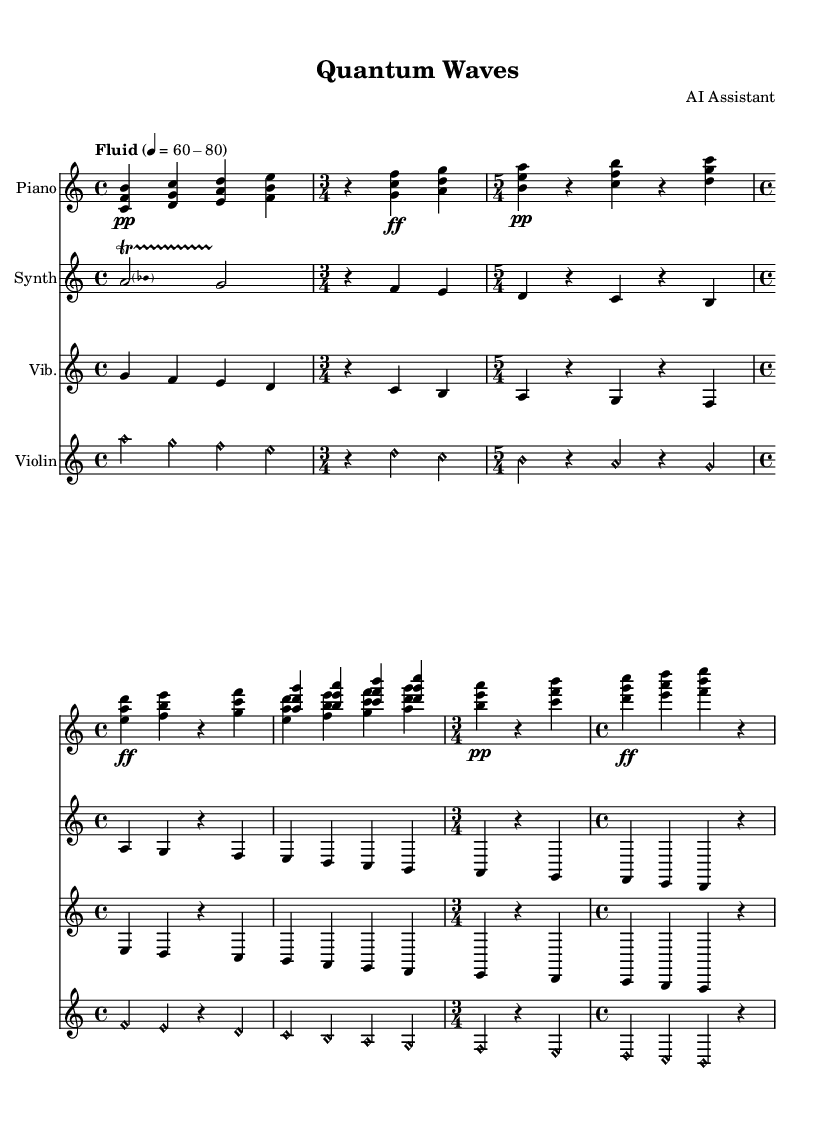What is the tempo marking of this composition? The tempo marking is indicated at the beginning of the score as "Fluid" with a range of 60-80 beats per minute, showing the desired pace for performance.
Answer: Fluid 60-80 What is the time signature of the first measure? The first measure has a time signature of 4/4, as explicitly notated at the beginning of the piece under the global settings.
Answer: 4/4 How many measures are there in the 'Collapse A' section? The 'Collapse A' section contains four measures, indicated by their distinctive rhythmic grouping of rests and notes under the appropriate time signature of 5/4.
Answer: 4 What is the highest pitch used in this piece? The highest pitch in the piece is the note 'a' in the violin part, which is located relative to the highest staff position, indicating its prominence.
Answer: a What unique compositional technique is employed in the 'Superposition AB' section? The 'Superposition AB' section utilizes a technique whereby two distinct musical lines are played simultaneously, reflecting the concept of superposition in quantum mechanics.
Answer: Superposition What instrument plays the 'Coda' section? The 'Coda' section is played by all four instruments: Piano, Synthesizer, Vibraphone, and Violin, as they all have respective notes indicated in that section.
Answer: All instruments How many instruments are present in this piece? There are four instruments present in this piece: Piano, Synthesizer, Vibraphone, and Violin, each with its own dedicated staff in the score.
Answer: Four 